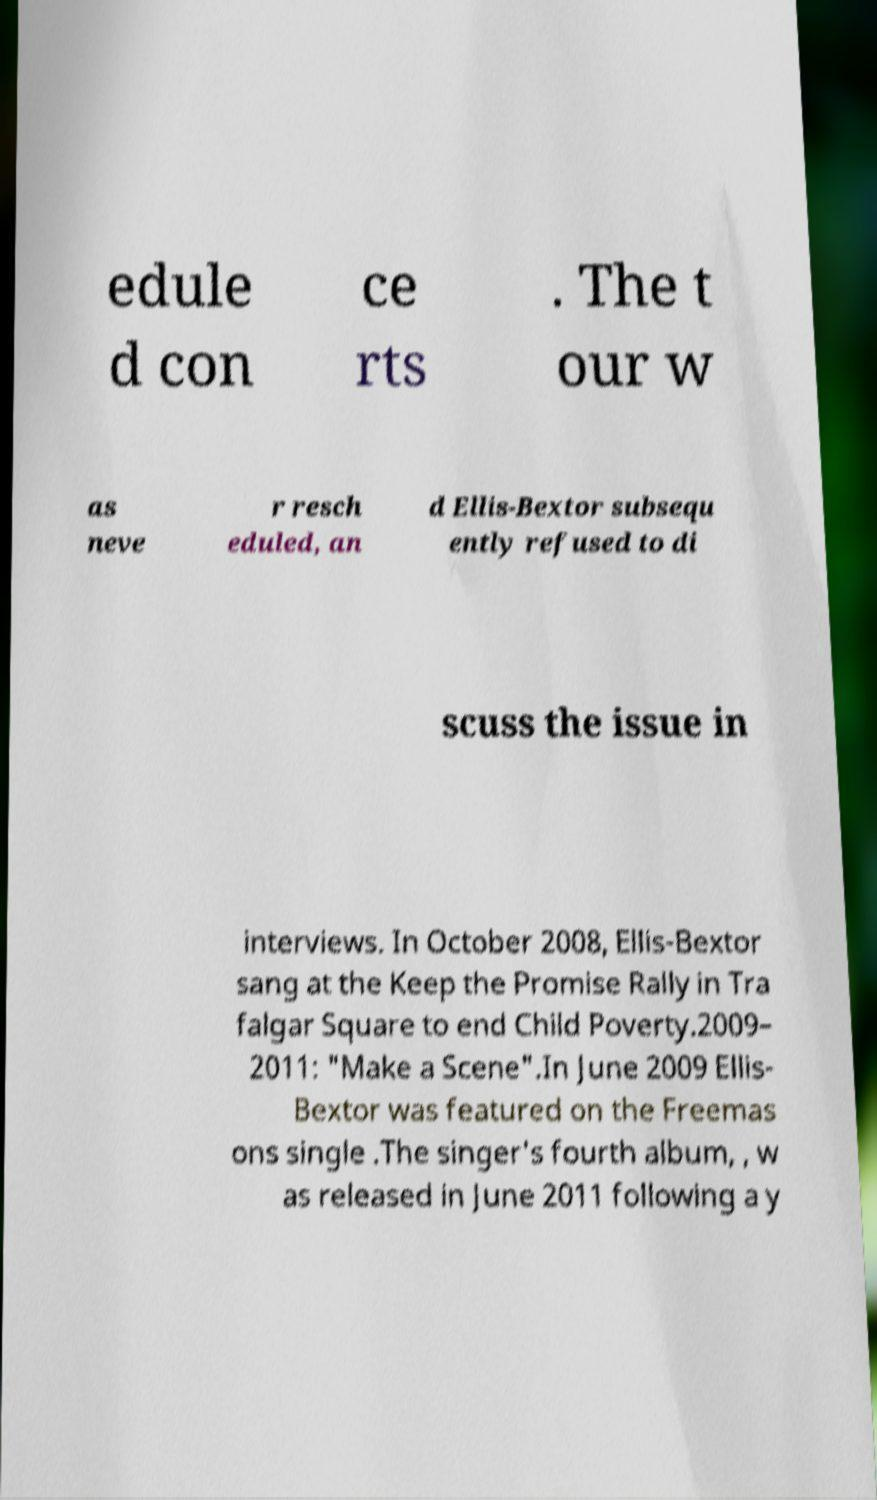What messages or text are displayed in this image? I need them in a readable, typed format. edule d con ce rts . The t our w as neve r resch eduled, an d Ellis-Bextor subsequ ently refused to di scuss the issue in interviews. In October 2008, Ellis-Bextor sang at the Keep the Promise Rally in Tra falgar Square to end Child Poverty.2009– 2011: "Make a Scene".In June 2009 Ellis- Bextor was featured on the Freemas ons single .The singer's fourth album, , w as released in June 2011 following a y 